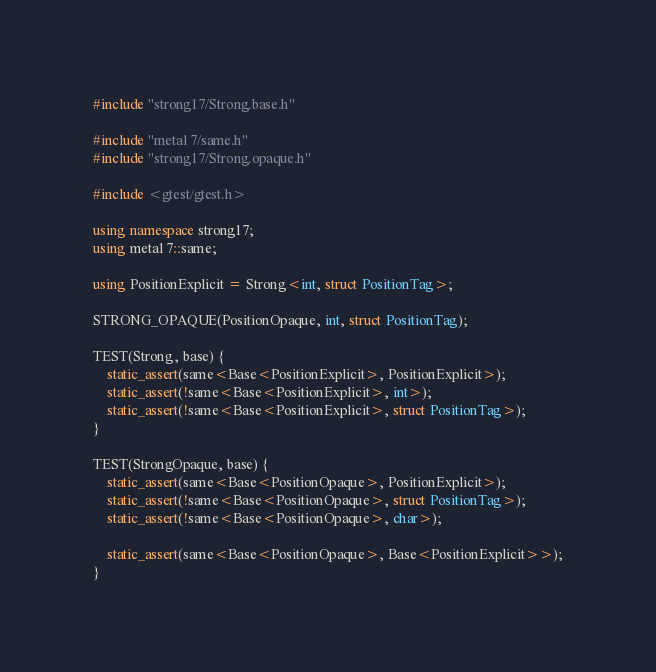Convert code to text. <code><loc_0><loc_0><loc_500><loc_500><_C++_>#include "strong17/Strong.base.h"

#include "meta17/same.h"
#include "strong17/Strong.opaque.h"

#include <gtest/gtest.h>

using namespace strong17;
using meta17::same;

using PositionExplicit = Strong<int, struct PositionTag>;

STRONG_OPAQUE(PositionOpaque, int, struct PositionTag);

TEST(Strong, base) {
    static_assert(same<Base<PositionExplicit>, PositionExplicit>);
    static_assert(!same<Base<PositionExplicit>, int>);
    static_assert(!same<Base<PositionExplicit>, struct PositionTag>);
}

TEST(StrongOpaque, base) {
    static_assert(same<Base<PositionOpaque>, PositionExplicit>);
    static_assert(!same<Base<PositionOpaque>, struct PositionTag>);
    static_assert(!same<Base<PositionOpaque>, char>);

    static_assert(same<Base<PositionOpaque>, Base<PositionExplicit>>);
}
</code> 